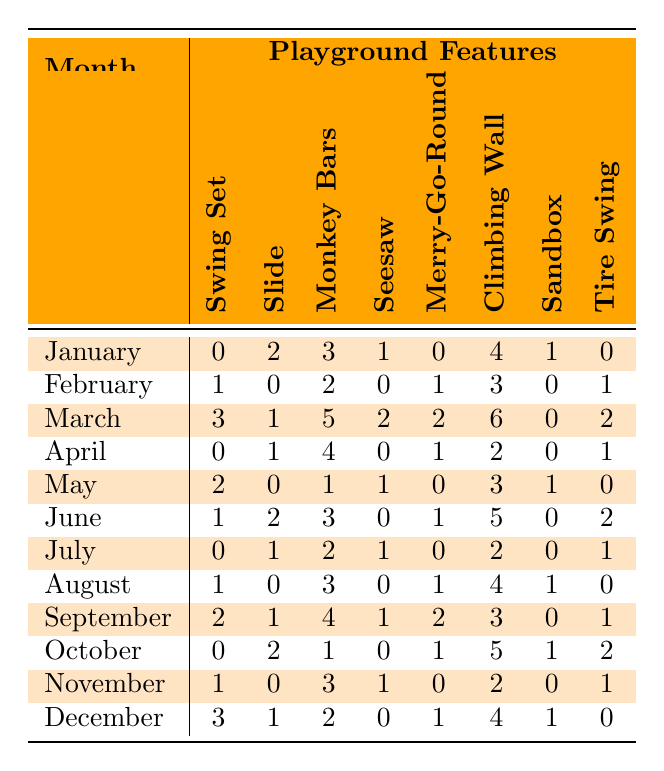What was the total number of safety incidents involving the Slide in March? To find the total safety incidents for the Slide in March, look at the March row under the Slide column, which shows '1'. Therefore, there were 1 incidents.
Answer: 1 In which month did the Climbing Wall have the highest number of safety incidents? Scanning the Climbing Wall column throughout the months, the highest value is '6' in March.
Answer: March What is the average number of safety incidents for the Swing Set over the entire year? The values for the Swing Set across all months are 0, 1, 3, 0, 2, 1, 0, 1, 2, 0, 1, and 3. Adding these gives a total of 14, and since there are 12 months, the average is 14/12: approximately 1.17.
Answer: 1.17 Did the Merry-Go-Round have more safety incidents in November than in December? For November, the total incidents of the Merry-Go-Round are '2' and for December, it's '4'. Since 2 is less than 4, the answer is no.
Answer: No Which playground feature had the most total safety incidents across the year? By summing each feature's incidents for all months: 
- Swing Set: 0+1+3+0+2+1+0+1+2+0+1+3 = 14
- Slide: 2+0+1+1+0+2+1+0+1+2+0+1 = 12
- Monkey Bars: 3+2+5+4+1+3+2+3+4+1+3+2 = 30
- Seesaw: 1+0+2+0+1+0+1+0+1+0+1+0 = 7
- Merry-Go-Round: 0+1+2+1+0+1+0+1+2+1+0+1 = 12
- Climbing Wall: 4+3+6+2+3+5+2+4+3+5+2+4 = 44
- Sandbox: 1+0+0+0+1+0+0+1+0+1+0+1 = 5
- Tire Swing: 0+1+2+1+0+2+1+0+1+2+1+0 = 12
Thus the Climbing Wall had the most with 44.
Answer: Climbing Wall How many months had no safety incidents for the Tire Swing? Checking the Tire Swing's row, it shows '0' in January, March, April, May, July, August, September, and December. That’s a total of 5 months.
Answer: 5 